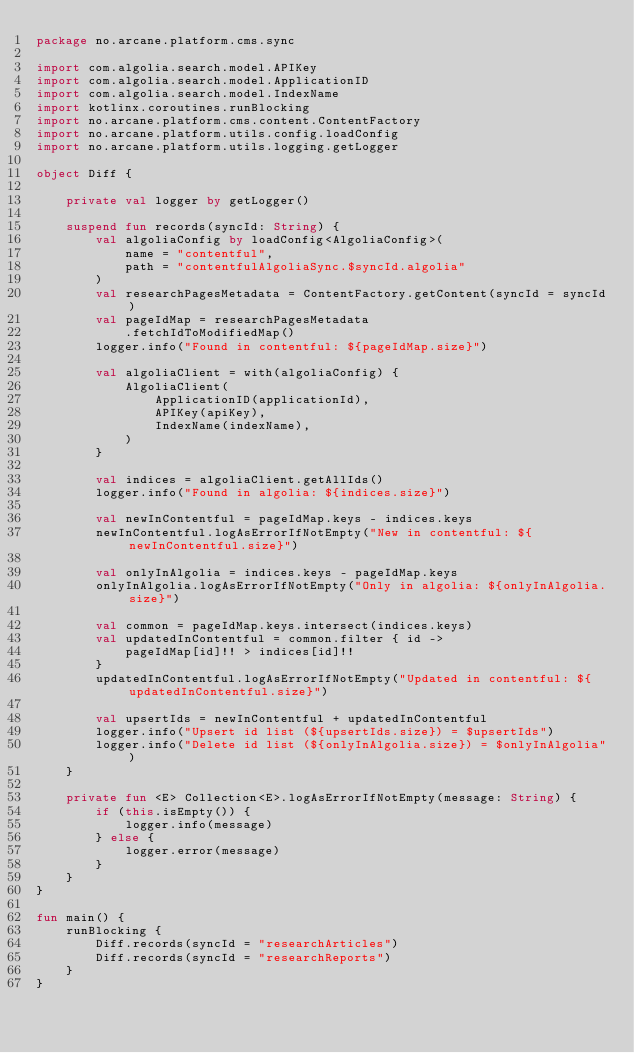<code> <loc_0><loc_0><loc_500><loc_500><_Kotlin_>package no.arcane.platform.cms.sync

import com.algolia.search.model.APIKey
import com.algolia.search.model.ApplicationID
import com.algolia.search.model.IndexName
import kotlinx.coroutines.runBlocking
import no.arcane.platform.cms.content.ContentFactory
import no.arcane.platform.utils.config.loadConfig
import no.arcane.platform.utils.logging.getLogger

object Diff {

    private val logger by getLogger()

    suspend fun records(syncId: String) {
        val algoliaConfig by loadConfig<AlgoliaConfig>(
            name = "contentful",
            path = "contentfulAlgoliaSync.$syncId.algolia"
        )
        val researchPagesMetadata = ContentFactory.getContent(syncId = syncId)
        val pageIdMap = researchPagesMetadata
            .fetchIdToModifiedMap()
        logger.info("Found in contentful: ${pageIdMap.size}")

        val algoliaClient = with(algoliaConfig) {
            AlgoliaClient(
                ApplicationID(applicationId),
                APIKey(apiKey),
                IndexName(indexName),
            )
        }

        val indices = algoliaClient.getAllIds()
        logger.info("Found in algolia: ${indices.size}")

        val newInContentful = pageIdMap.keys - indices.keys
        newInContentful.logAsErrorIfNotEmpty("New in contentful: ${newInContentful.size}")

        val onlyInAlgolia = indices.keys - pageIdMap.keys
        onlyInAlgolia.logAsErrorIfNotEmpty("Only in algolia: ${onlyInAlgolia.size}")

        val common = pageIdMap.keys.intersect(indices.keys)
        val updatedInContentful = common.filter { id ->
            pageIdMap[id]!! > indices[id]!!
        }
        updatedInContentful.logAsErrorIfNotEmpty("Updated in contentful: ${updatedInContentful.size}")

        val upsertIds = newInContentful + updatedInContentful
        logger.info("Upsert id list (${upsertIds.size}) = $upsertIds")
        logger.info("Delete id list (${onlyInAlgolia.size}) = $onlyInAlgolia")
    }

    private fun <E> Collection<E>.logAsErrorIfNotEmpty(message: String) {
        if (this.isEmpty()) {
            logger.info(message)
        } else {
            logger.error(message)
        }
    }
}

fun main() {
    runBlocking {
        Diff.records(syncId = "researchArticles")
        Diff.records(syncId = "researchReports")
    }
}</code> 